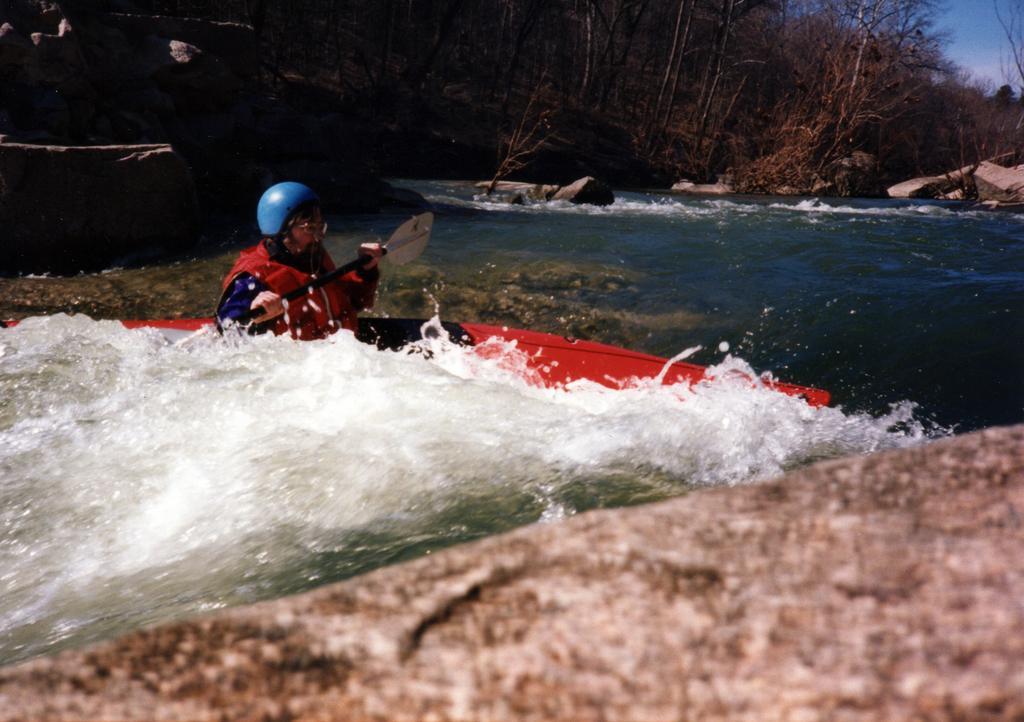Could you give a brief overview of what you see in this image? In this image we can see a person rowing a boat on the water and in the background there are rocks, trees and sky. 